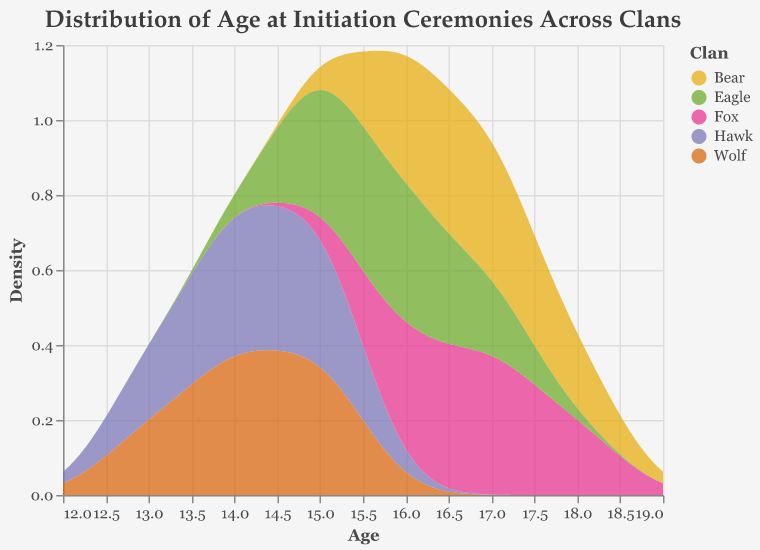What is the title of the plot? The title of the plot can be found at the top and is easy to read.
Answer: Distribution of Age at Initiation Ceremonies Across Clans What are the names of the clans represented in the plot? You can identify the clan names from the legend on the right side of the plot.
Answer: Hawk, Bear, Wolf, Fox, Eagle What age range does the x-axis cover? The x-axis displays the range of ages, and by looking at the axis labels, you can determine the covered range.
Answer: 12 to 19 years Which clan has the highest density at age 15? By observing the peaks of the density curves at age 15, you can identify which clan reaches the highest density.
Answer: Hawk Which clans show a peak density at age 16? By examining the density curves, note which ones peak at age 16.
Answer: Bear, Fox, Eagle Between which ages does the Fox clan’s density curve extend? Look at the density area specific to the Fox clan to determine the age range it covers.
Answer: 16 to 18 years Which clan has the broadest range of ages with significant density? Identify the clan with the density curve spanning the widest age range.
Answer: Bear How does the density of the Hawk clan at age 14 compare to that at age 15? Compare the heights of the density curve for the Hawk clan at ages 14 and 15 to determine their relative values.
Answer: Higher at age 15 What is the general shape of the density plot for the Wolf clan? Observe the Wolf clan’s density curve to describe its overall shape and characteristics.
Answer: Bimodal with peaks at ages 14 and 15 What is the average peak age of initiation for all clans combined? Average the peak ages of the density curves for all clans to determine the overall average peak age.
Answer: 16 years 